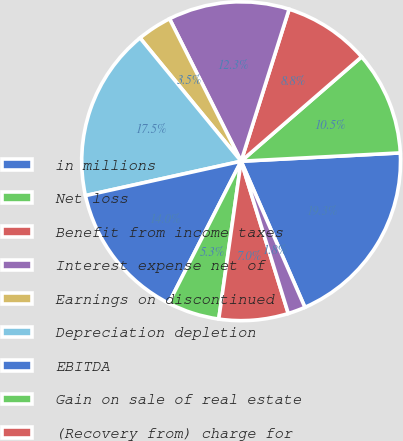Convert chart to OTSL. <chart><loc_0><loc_0><loc_500><loc_500><pie_chart><fcel>in millions<fcel>Net loss<fcel>Benefit from income taxes<fcel>Interest expense net of<fcel>Earnings on discontinued<fcel>Depreciation depletion<fcel>EBITDA<fcel>Gain on sale of real estate<fcel>(Recovery from) charge for<fcel>Restructuring charges<nl><fcel>19.28%<fcel>10.53%<fcel>8.77%<fcel>12.28%<fcel>3.52%<fcel>17.53%<fcel>14.03%<fcel>5.27%<fcel>7.02%<fcel>1.77%<nl></chart> 